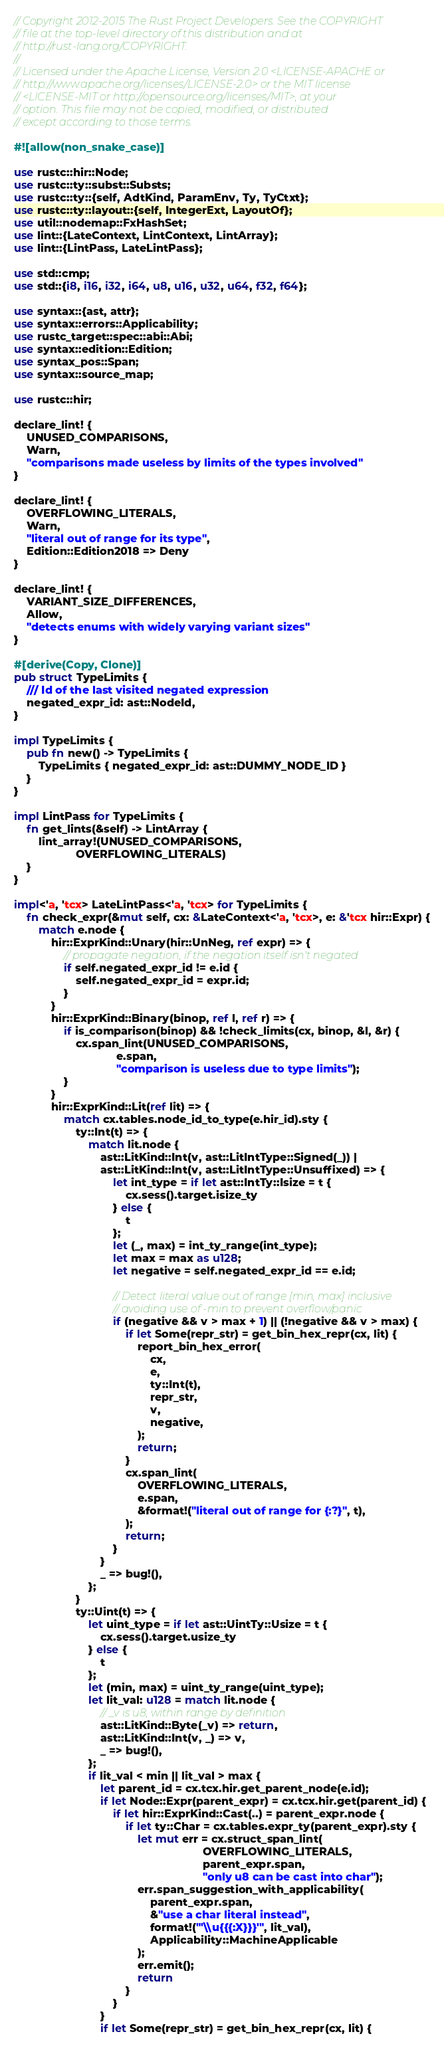Convert code to text. <code><loc_0><loc_0><loc_500><loc_500><_Rust_>// Copyright 2012-2015 The Rust Project Developers. See the COPYRIGHT
// file at the top-level directory of this distribution and at
// http://rust-lang.org/COPYRIGHT.
//
// Licensed under the Apache License, Version 2.0 <LICENSE-APACHE or
// http://www.apache.org/licenses/LICENSE-2.0> or the MIT license
// <LICENSE-MIT or http://opensource.org/licenses/MIT>, at your
// option. This file may not be copied, modified, or distributed
// except according to those terms.

#![allow(non_snake_case)]

use rustc::hir::Node;
use rustc::ty::subst::Substs;
use rustc::ty::{self, AdtKind, ParamEnv, Ty, TyCtxt};
use rustc::ty::layout::{self, IntegerExt, LayoutOf};
use util::nodemap::FxHashSet;
use lint::{LateContext, LintContext, LintArray};
use lint::{LintPass, LateLintPass};

use std::cmp;
use std::{i8, i16, i32, i64, u8, u16, u32, u64, f32, f64};

use syntax::{ast, attr};
use syntax::errors::Applicability;
use rustc_target::spec::abi::Abi;
use syntax::edition::Edition;
use syntax_pos::Span;
use syntax::source_map;

use rustc::hir;

declare_lint! {
    UNUSED_COMPARISONS,
    Warn,
    "comparisons made useless by limits of the types involved"
}

declare_lint! {
    OVERFLOWING_LITERALS,
    Warn,
    "literal out of range for its type",
    Edition::Edition2018 => Deny
}

declare_lint! {
    VARIANT_SIZE_DIFFERENCES,
    Allow,
    "detects enums with widely varying variant sizes"
}

#[derive(Copy, Clone)]
pub struct TypeLimits {
    /// Id of the last visited negated expression
    negated_expr_id: ast::NodeId,
}

impl TypeLimits {
    pub fn new() -> TypeLimits {
        TypeLimits { negated_expr_id: ast::DUMMY_NODE_ID }
    }
}

impl LintPass for TypeLimits {
    fn get_lints(&self) -> LintArray {
        lint_array!(UNUSED_COMPARISONS,
                    OVERFLOWING_LITERALS)
    }
}

impl<'a, 'tcx> LateLintPass<'a, 'tcx> for TypeLimits {
    fn check_expr(&mut self, cx: &LateContext<'a, 'tcx>, e: &'tcx hir::Expr) {
        match e.node {
            hir::ExprKind::Unary(hir::UnNeg, ref expr) => {
                // propagate negation, if the negation itself isn't negated
                if self.negated_expr_id != e.id {
                    self.negated_expr_id = expr.id;
                }
            }
            hir::ExprKind::Binary(binop, ref l, ref r) => {
                if is_comparison(binop) && !check_limits(cx, binop, &l, &r) {
                    cx.span_lint(UNUSED_COMPARISONS,
                                 e.span,
                                 "comparison is useless due to type limits");
                }
            }
            hir::ExprKind::Lit(ref lit) => {
                match cx.tables.node_id_to_type(e.hir_id).sty {
                    ty::Int(t) => {
                        match lit.node {
                            ast::LitKind::Int(v, ast::LitIntType::Signed(_)) |
                            ast::LitKind::Int(v, ast::LitIntType::Unsuffixed) => {
                                let int_type = if let ast::IntTy::Isize = t {
                                    cx.sess().target.isize_ty
                                } else {
                                    t
                                };
                                let (_, max) = int_ty_range(int_type);
                                let max = max as u128;
                                let negative = self.negated_expr_id == e.id;

                                // Detect literal value out of range [min, max] inclusive
                                // avoiding use of -min to prevent overflow/panic
                                if (negative && v > max + 1) || (!negative && v > max) {
                                    if let Some(repr_str) = get_bin_hex_repr(cx, lit) {
                                        report_bin_hex_error(
                                            cx,
                                            e,
                                            ty::Int(t),
                                            repr_str,
                                            v,
                                            negative,
                                        );
                                        return;
                                    }
                                    cx.span_lint(
                                        OVERFLOWING_LITERALS,
                                        e.span,
                                        &format!("literal out of range for {:?}", t),
                                    );
                                    return;
                                }
                            }
                            _ => bug!(),
                        };
                    }
                    ty::Uint(t) => {
                        let uint_type = if let ast::UintTy::Usize = t {
                            cx.sess().target.usize_ty
                        } else {
                            t
                        };
                        let (min, max) = uint_ty_range(uint_type);
                        let lit_val: u128 = match lit.node {
                            // _v is u8, within range by definition
                            ast::LitKind::Byte(_v) => return,
                            ast::LitKind::Int(v, _) => v,
                            _ => bug!(),
                        };
                        if lit_val < min || lit_val > max {
                            let parent_id = cx.tcx.hir.get_parent_node(e.id);
                            if let Node::Expr(parent_expr) = cx.tcx.hir.get(parent_id) {
                                if let hir::ExprKind::Cast(..) = parent_expr.node {
                                    if let ty::Char = cx.tables.expr_ty(parent_expr).sty {
                                        let mut err = cx.struct_span_lint(
                                                             OVERFLOWING_LITERALS,
                                                             parent_expr.span,
                                                             "only u8 can be cast into char");
                                        err.span_suggestion_with_applicability(
                                            parent_expr.span,
                                            &"use a char literal instead",
                                            format!("'\\u{{{:X}}}'", lit_val),
                                            Applicability::MachineApplicable
                                        );
                                        err.emit();
                                        return
                                    }
                                }
                            }
                            if let Some(repr_str) = get_bin_hex_repr(cx, lit) {</code> 